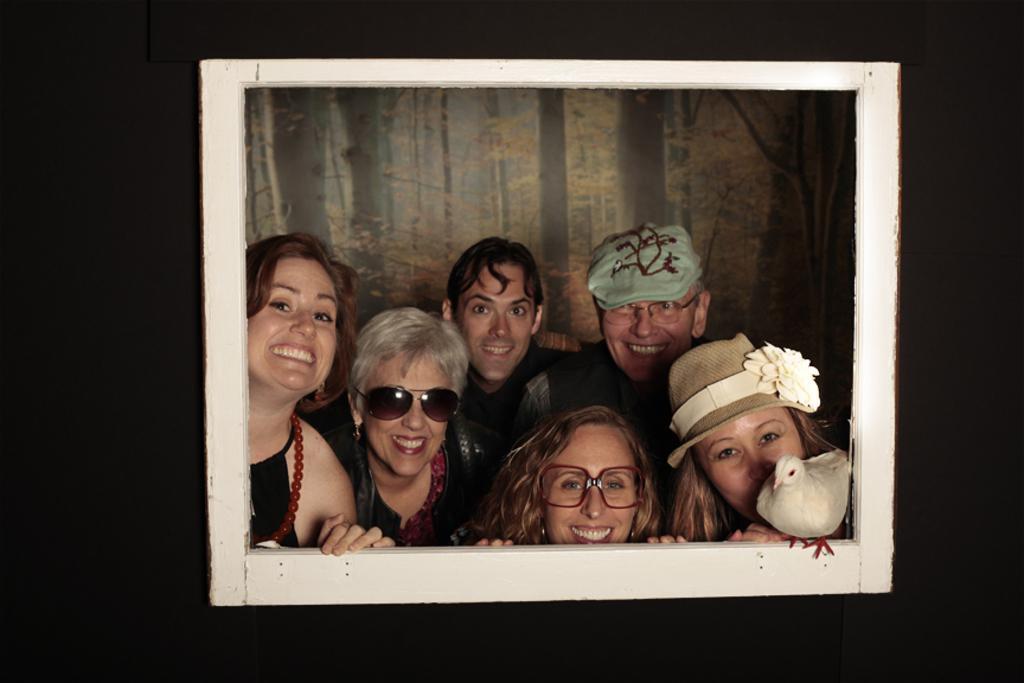Can you describe this image briefly? In this image we can see a picture frame and people inside the frame and a bird on the frame and in the background there is a scenery of trees. 